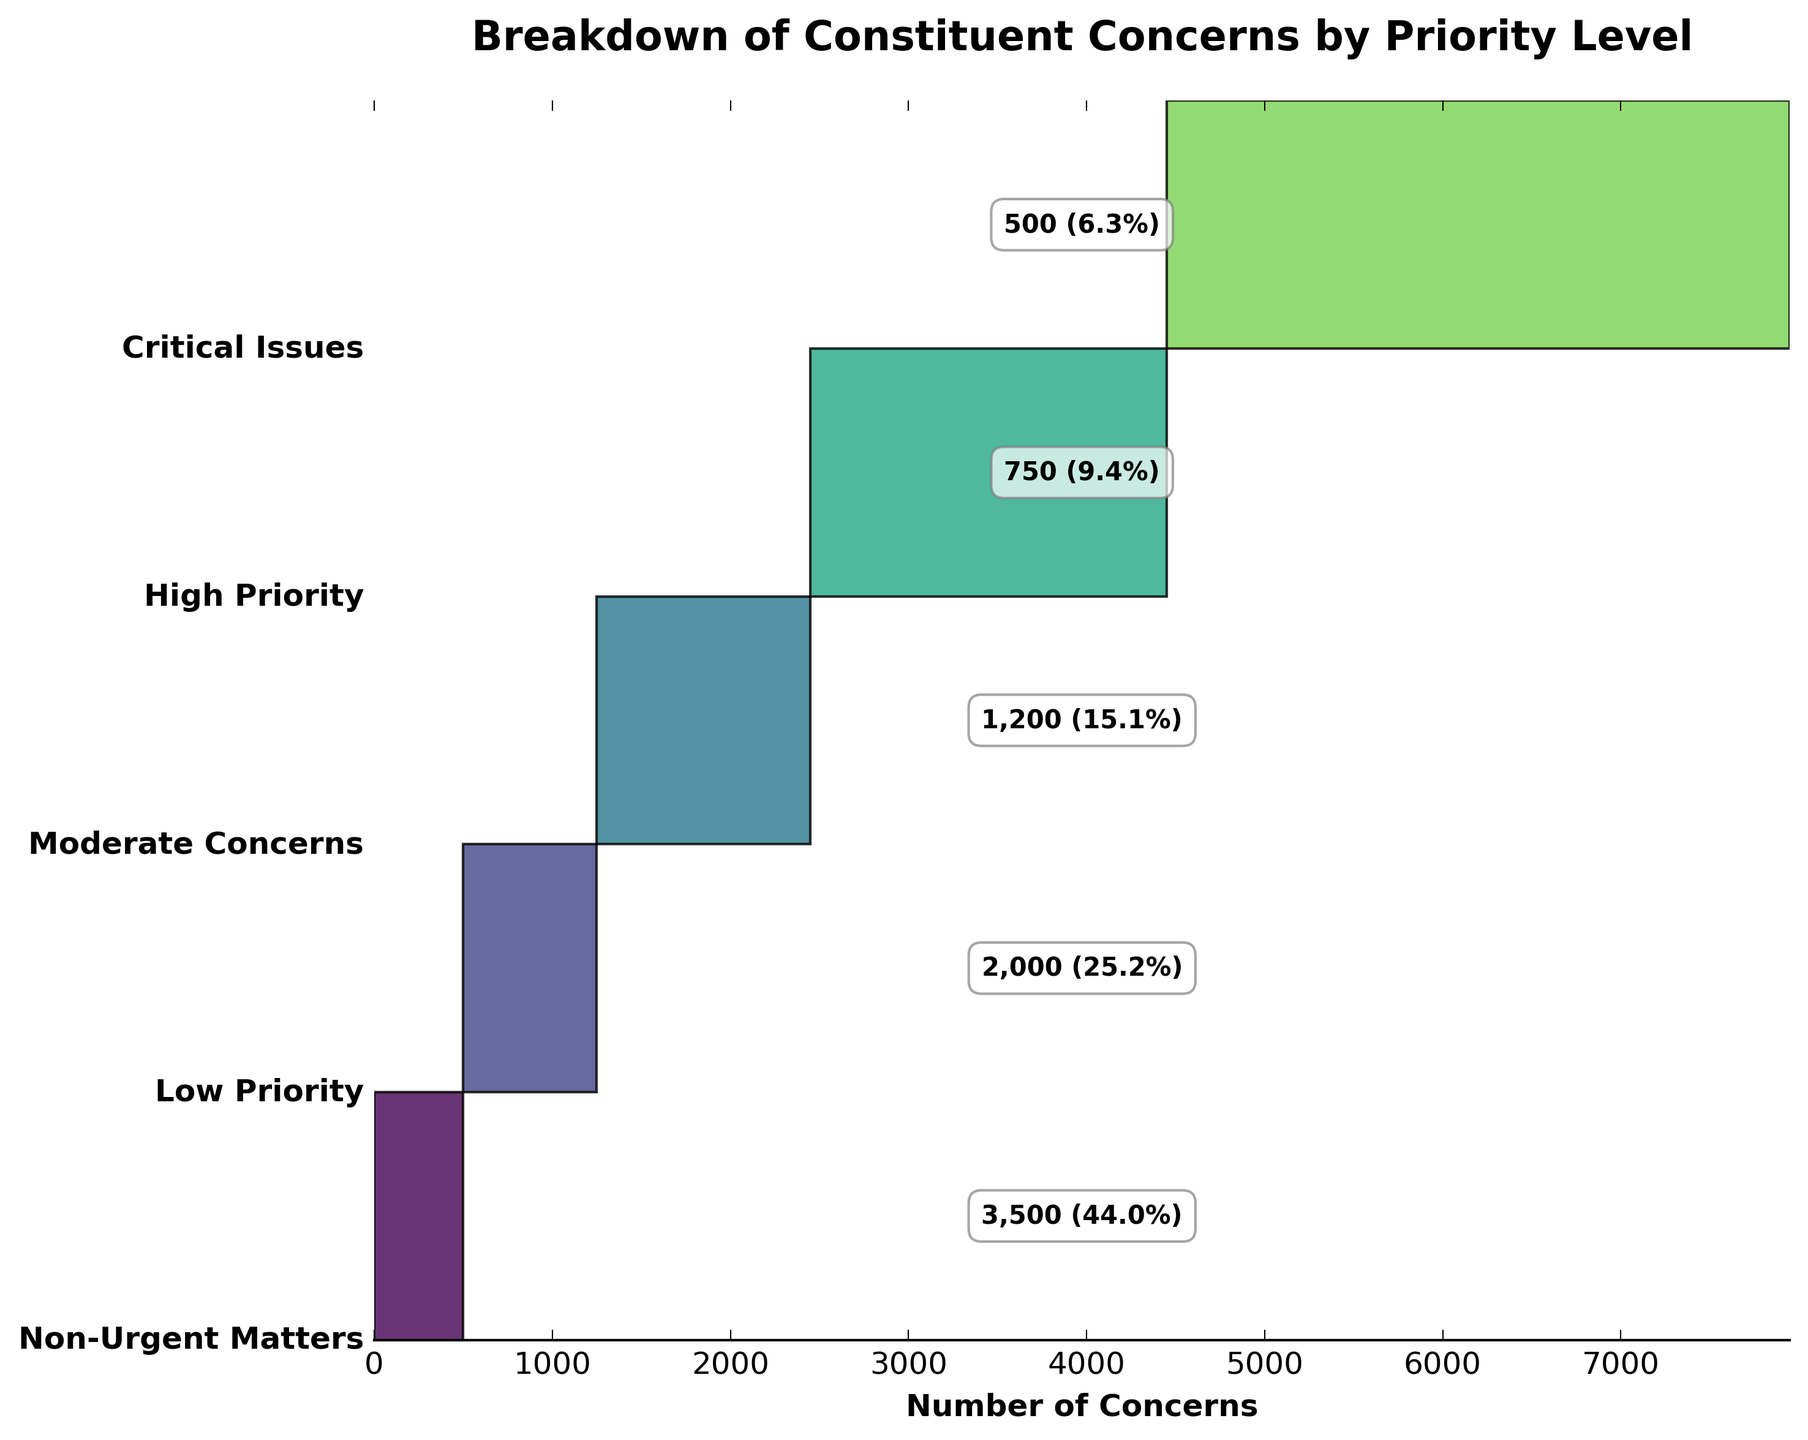What is the title of the funnel chart? The title is located at the top of the funnel chart in larger, bold font. It provides a brief description of what the chart is about.
Answer: Breakdown of Constituent Concerns by Priority Level What is the total number of concerns represented in the chart? The total number can be found by adding up the values given for each priority level: 500 + 750 + 1200 + 2000 + 3500.
Answer: 7950 Which priority level has the highest number of concerns? By looking at the funnel chart, the widest section represents the category with the highest number of concerns.
Answer: Non-Urgent Matters Which priority level accounts for the smallest portion of concerns? The narrowest section of the funnel chart represents the category with the smallest number of concerns.
Answer: Critical Issues How many more concerns are there in High Priority compared to Low Priority? Subtract the number of concerns in Low Priority from the number in High Priority: 750 - 2000.
Answer: -1250 Which priority levels fall in the middle of the chart, and how many concerns do they represent together? Look at the middle sections of the funnel chart and add the corresponding numbers of concerns: Moderate Concerns and High Priority, which are 1200 and 750 respectively: 1200 + 750.
Answer: 1950 What percentage of the total concerns are categorized as Moderate Concerns? The number of Moderate Concerns divided by the total number of concerns multiplied by 100%: (1200 / 7950) * 100.
Answer: 15.1% Which two priority levels have the closest number of concerns, and what is the difference between them? By examining the chart and comparing the sections visually and numerically: Moderate Concerns and High Priority. Calculate: 1200 - 750.
Answer: 450 By how much do the concerns categorized as Low Priority exceed those in Critical Issues? Subtract the number of concerns in Critical Issues from the number in Low Priority: 2000 - 500.
Answer: 1500 What proportion of concerns are either Critical Issues or Non-Urgent Matters, and how does it relate to the total? Add the number of concerns in both categories and then divide by the total number, finally multiply by 100%: ((500 + 3500) / 7950) * 100.
Answer: 50.3% 